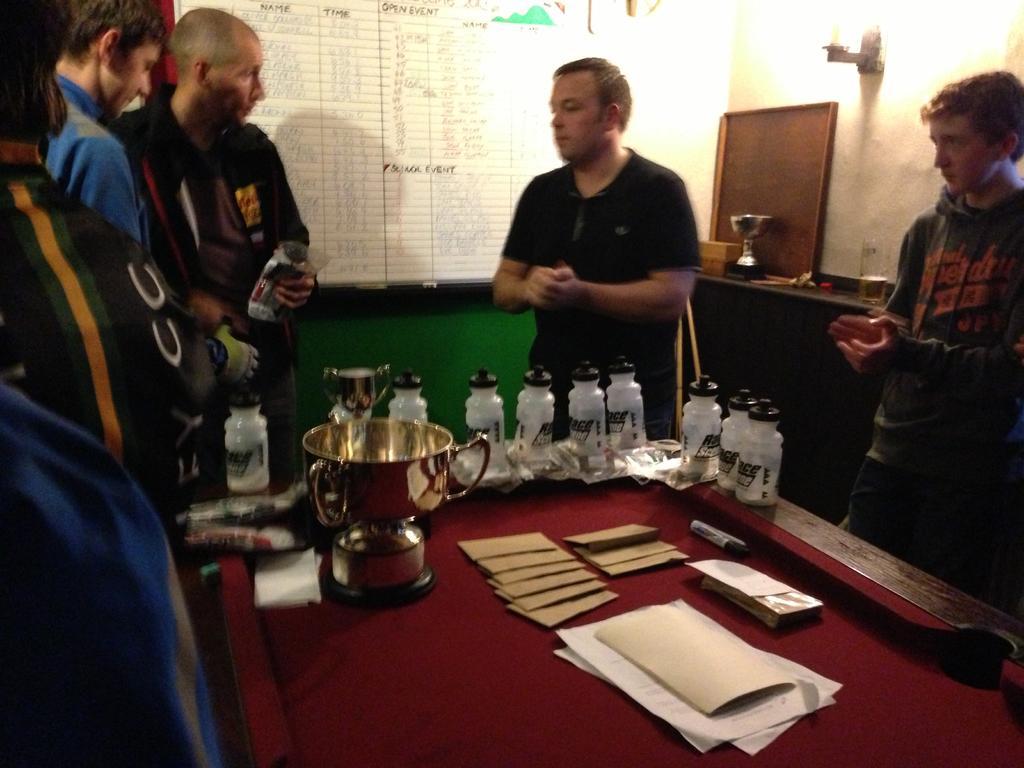How would you summarize this image in a sentence or two? In this picture there are several people standing around the table and containers and books on top of it. In the background we observe a white board and a brown color table on top of which objects are placed. 